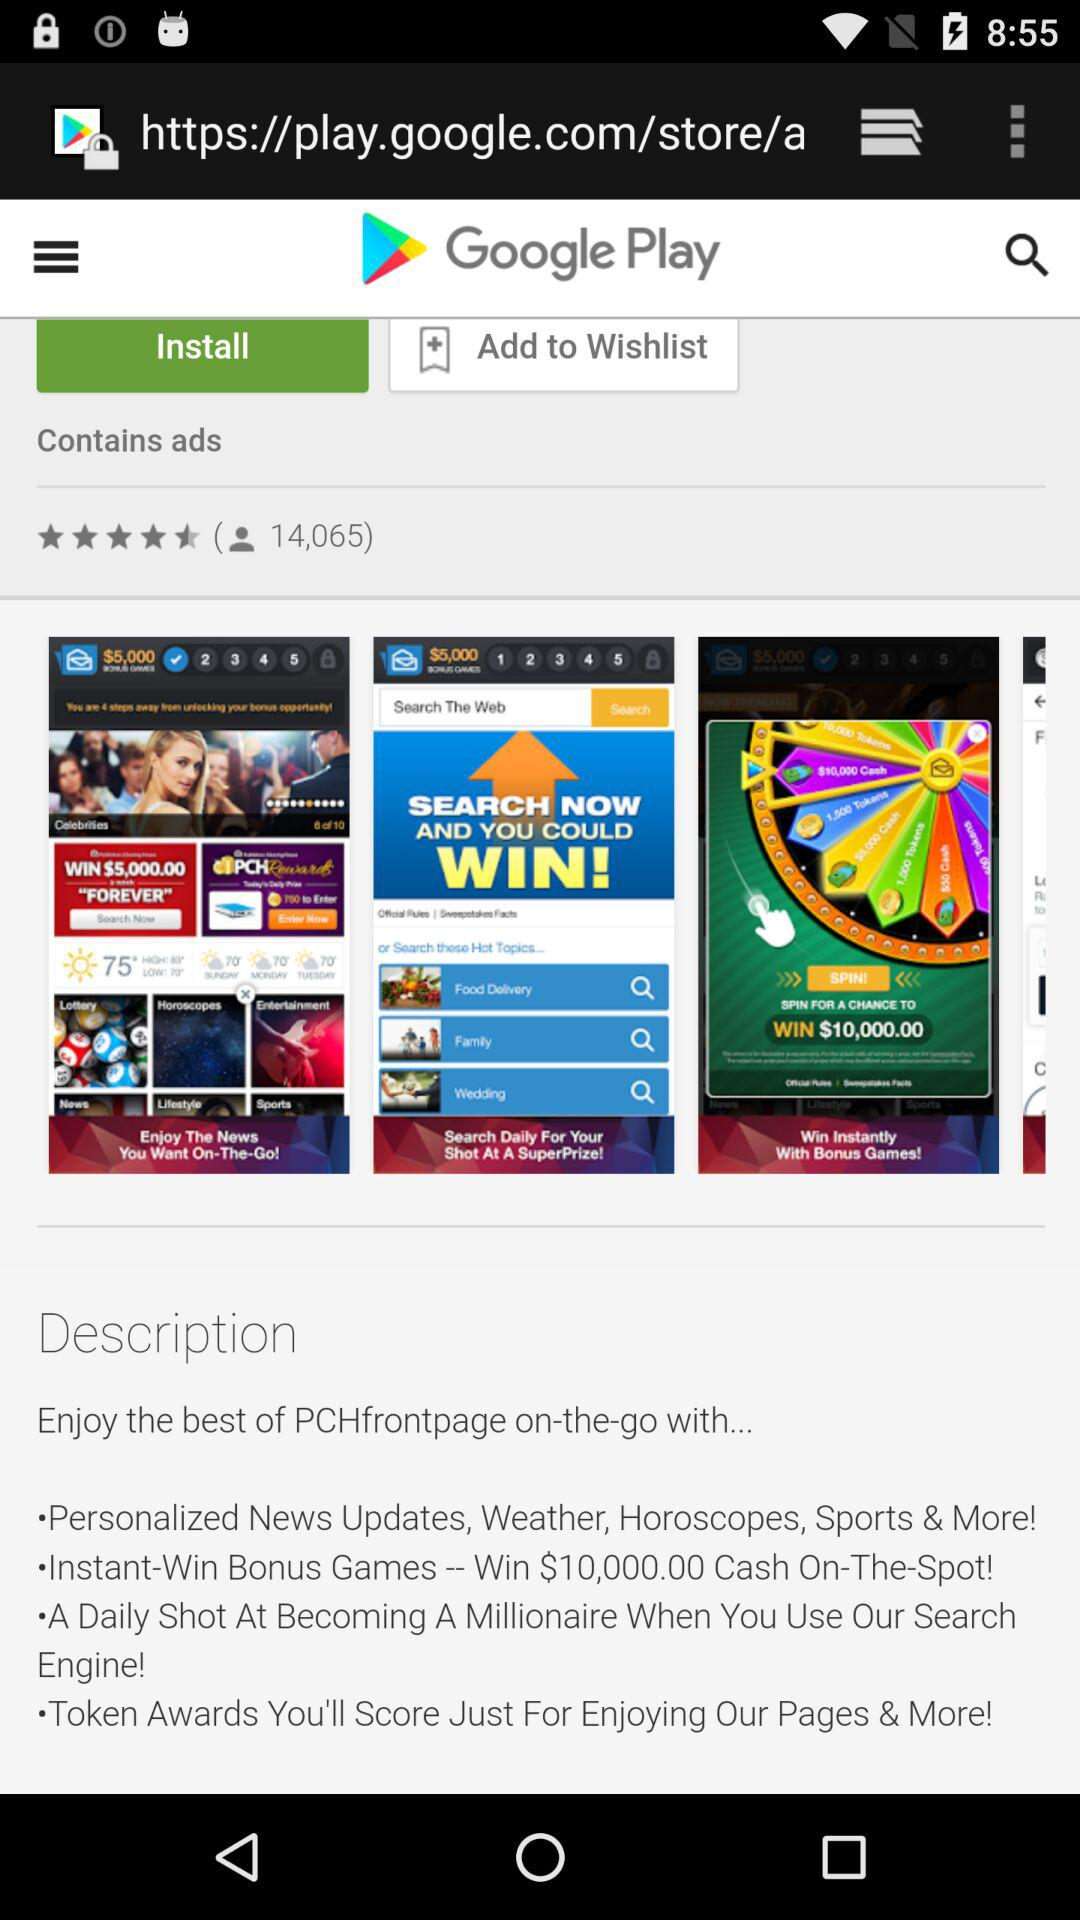How many people reviewed the app? The people who reviewed the app are 14,065. 